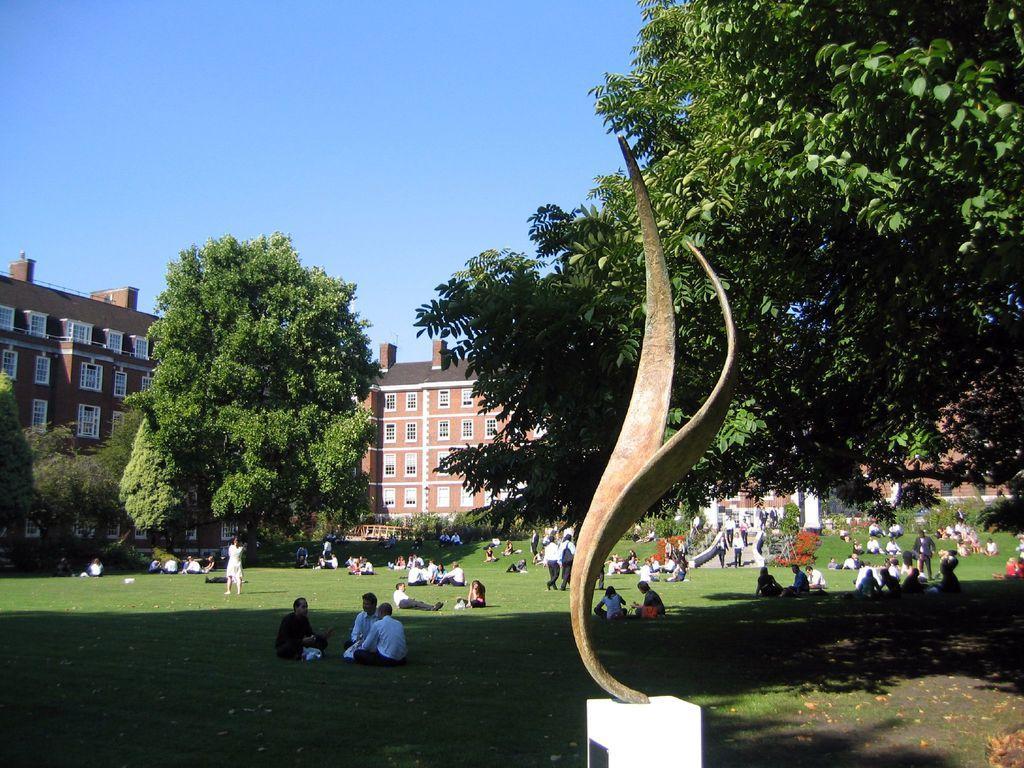Describe this image in one or two sentences. In this picture we can see a sculpture on a pedestal stone, some people are walking, some people are sitting on the grass, trees, some objects, buildings with windows and in the background we can see the sky. 